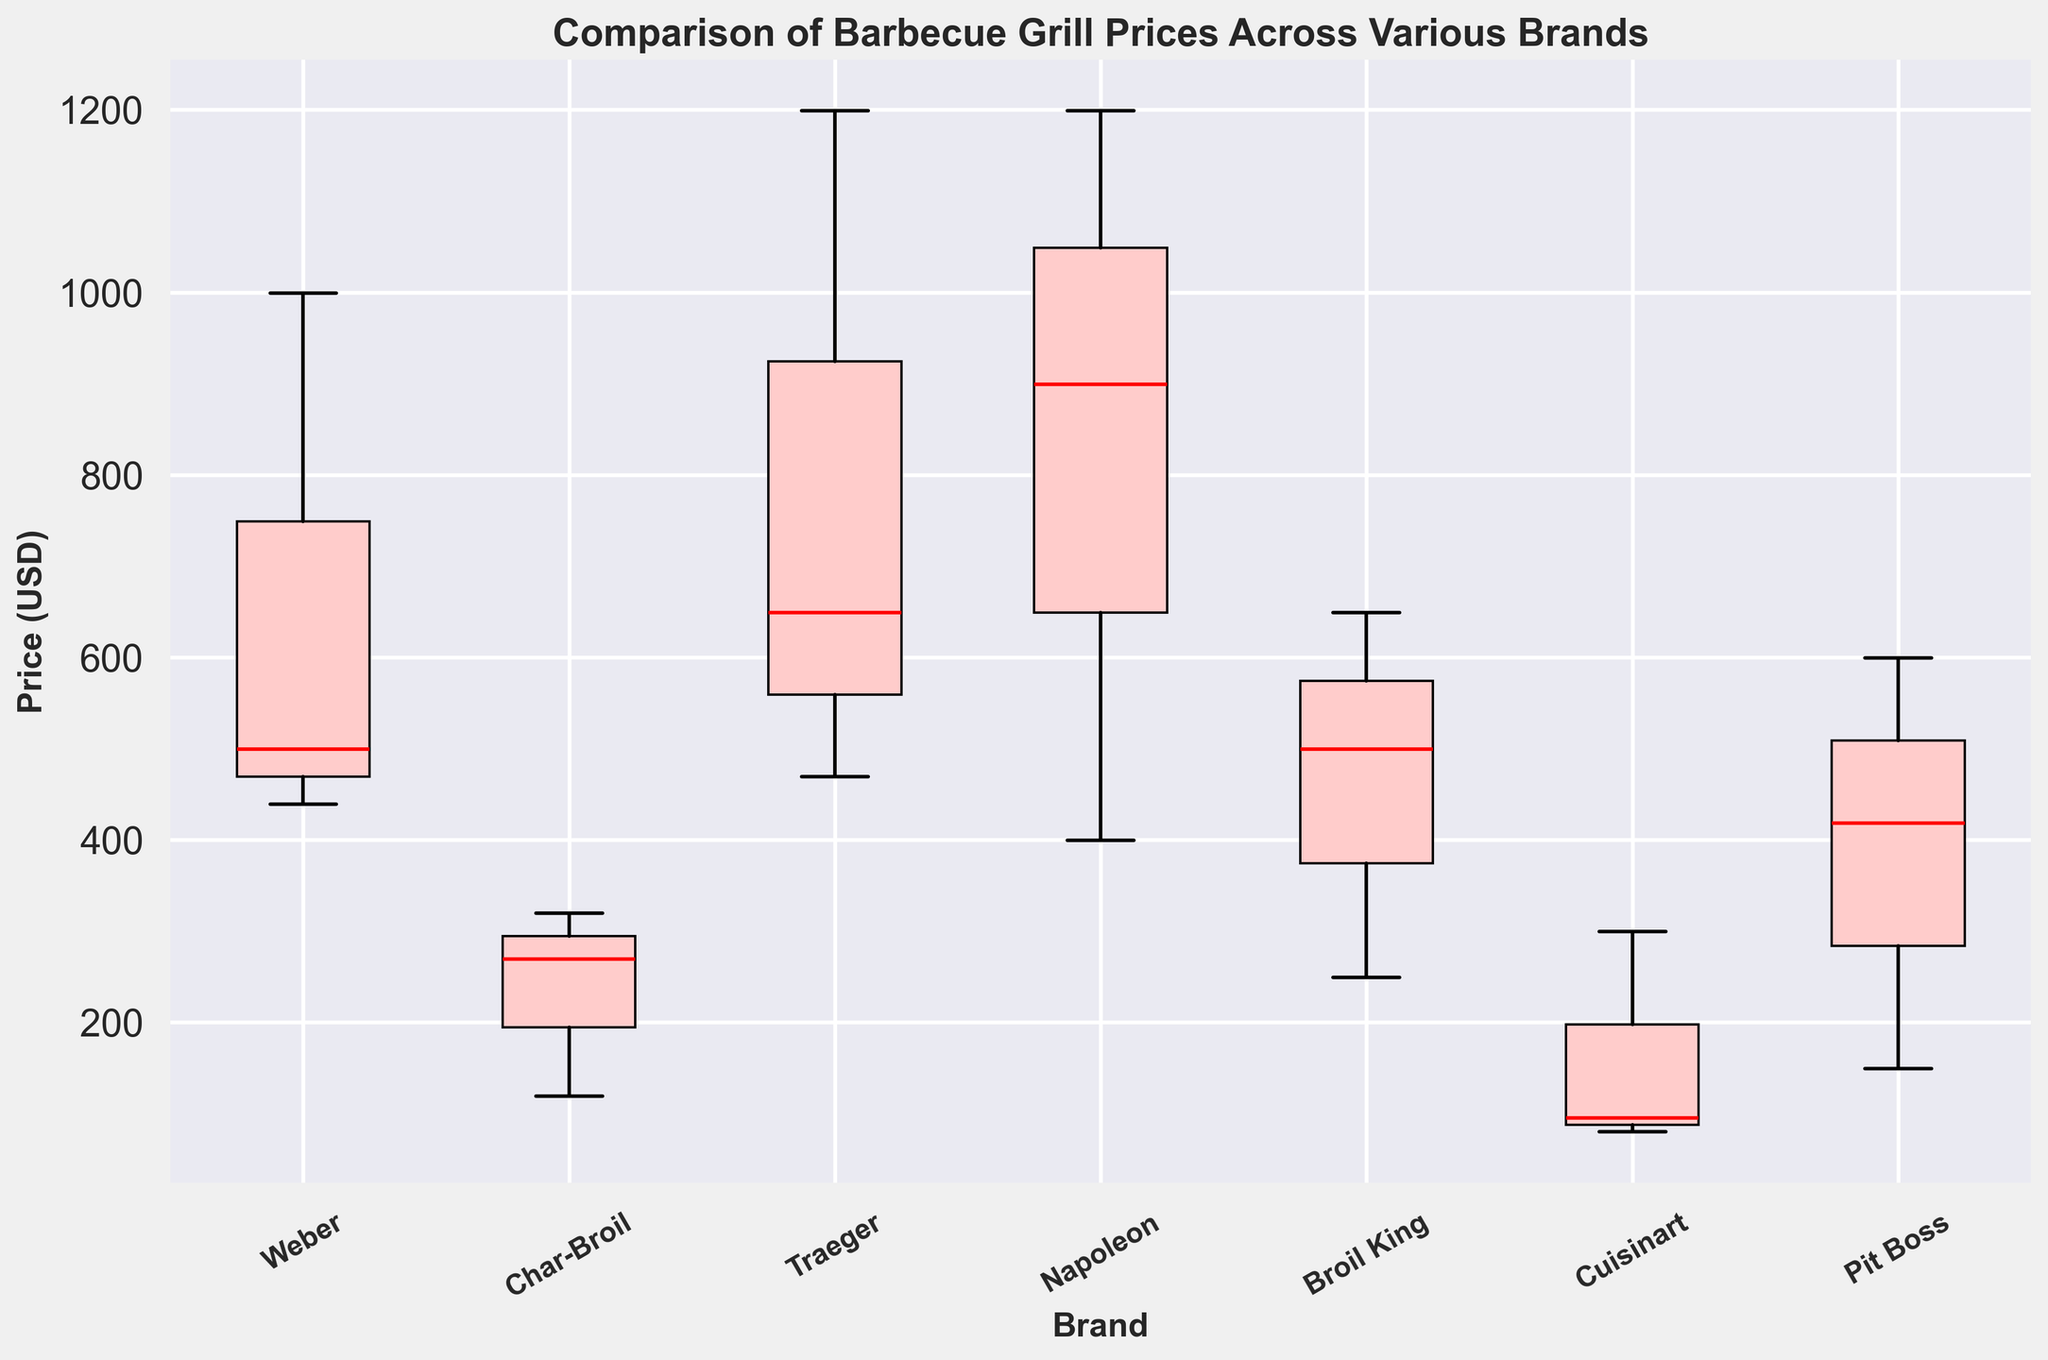What brand has the highest variability in barbecue grill prices? To determine the variability, look at the length of the box (interquartile range) and the length of the whiskers. Traeger has the widest spread, indicating the highest variability in prices.
Answer: Traeger Which brand has the lowest median price for its grills? The median is represented by the red line within each box. Cuisinart has the lowest median price, easily identifiable as its red line is at the bottom compared to other brands.
Answer: Cuisinart What is the interquartile range (IQR) of the Weber grills? The IQR is the range between the first quartile (25th percentile) and the third quartile (75th percentile). For Weber, locate the bottom and top of the box. The IQR appears to be roughly from $439 to $999, which is $999 - $439 = $560.
Answer: $560 Which brand has the highest grill price and what is the price? Observe the upper whiskers and any outliers. The highest price is for Napoleon, and the top of Napoleon's whisker touches $1199.
Answer: Napoleon, $1199 What is the price range for Char-Broil grills? The price range is the difference between the maximum and minimum prices for Char-Broil. Locate the top of the upper whisker and the bottom of the lower whisker for Char-Broil, which appears to be between $119 and $319, making the range $319 - $119 = $200.
Answer: $200 How does the median price of Pit Boss compare to Broil King's median price? Compare the red lines within the boxes for Pit Boss and Broil King. The median price for Pit Boss appears higher than that of Broil King.
Answer: Pit Boss' median is higher Are any brands' grill prices displayed as outliers? If so, which ones? Outliers are single data points that fall far outside the whiskers. Notice that none of the brands have dots or markers outside the whiskers, indicating there are no outliers.
Answer: No brands have outliers Which brands have median prices above $500? Identify the brands whose red median lines are above the $500 mark on the y-axis. Napoleon, Traeger, and Weber have median prices above $500.
Answer: Napoleon, Traeger, Weber Between Char-Broil and Broil King, which brand offers a lower-priced grill? Look at the bottom end of the boxes or whiskers. The lowest price within Char-Broil is $119, while for Broil King, it's $249. So, Char-Broil offers a lower-priced grill.
Answer: Char-Broil 